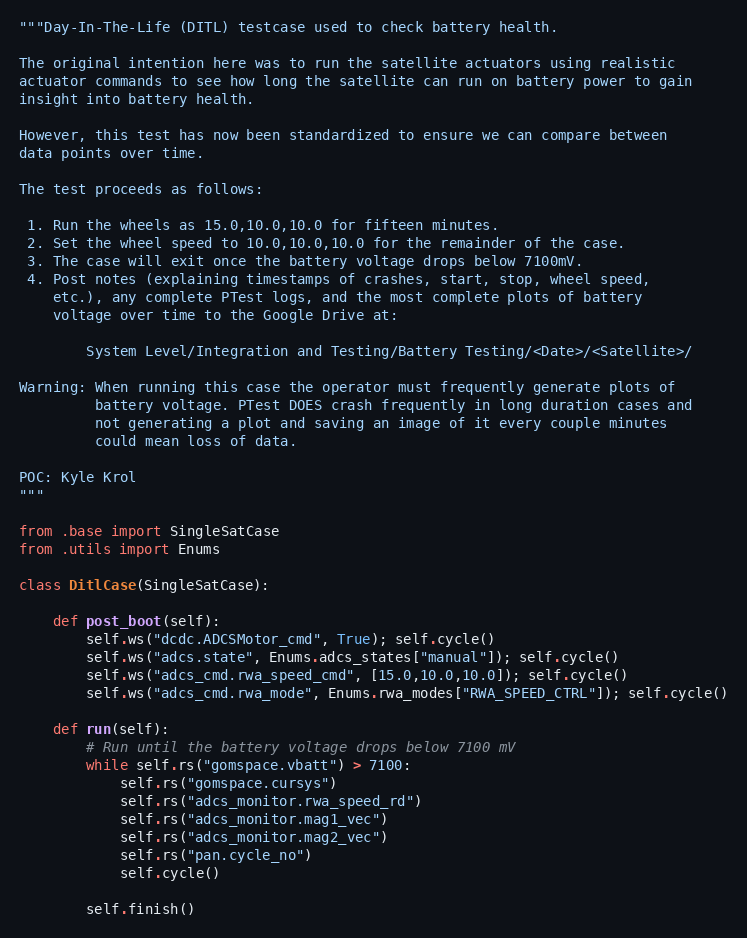Convert code to text. <code><loc_0><loc_0><loc_500><loc_500><_Python_>"""Day-In-The-Life (DITL) testcase used to check battery health.

The original intention here was to run the satellite actuators using realistic
actuator commands to see how long the satellite can run on battery power to gain
insight into battery health.

However, this test has now been standardized to ensure we can compare between
data points over time.

The test proceeds as follows:

 1. Run the wheels as 15.0,10.0,10.0 for fifteen minutes.
 2. Set the wheel speed to 10.0,10.0,10.0 for the remainder of the case.
 3. The case will exit once the battery voltage drops below 7100mV.
 4. Post notes (explaining timestamps of crashes, start, stop, wheel speed,
    etc.), any complete PTest logs, and the most complete plots of battery
    voltage over time to the Google Drive at:

        System Level/Integration and Testing/Battery Testing/<Date>/<Satellite>/

Warning: When running this case the operator must frequently generate plots of
         battery voltage. PTest DOES crash frequently in long duration cases and
         not generating a plot and saving an image of it every couple minutes
         could mean loss of data.

POC: Kyle Krol
"""

from .base import SingleSatCase
from .utils import Enums

class DitlCase(SingleSatCase):

    def post_boot(self):
        self.ws("dcdc.ADCSMotor_cmd", True); self.cycle()
        self.ws("adcs.state", Enums.adcs_states["manual"]); self.cycle()
        self.ws("adcs_cmd.rwa_speed_cmd", [15.0,10.0,10.0]); self.cycle()
        self.ws("adcs_cmd.rwa_mode", Enums.rwa_modes["RWA_SPEED_CTRL"]); self.cycle()

    def run(self):
        # Run until the battery voltage drops below 7100 mV
        while self.rs("gomspace.vbatt") > 7100:
            self.rs("gomspace.cursys")
            self.rs("adcs_monitor.rwa_speed_rd")
            self.rs("adcs_monitor.mag1_vec")
            self.rs("adcs_monitor.mag2_vec")
            self.rs("pan.cycle_no")
            self.cycle()

        self.finish()
</code> 